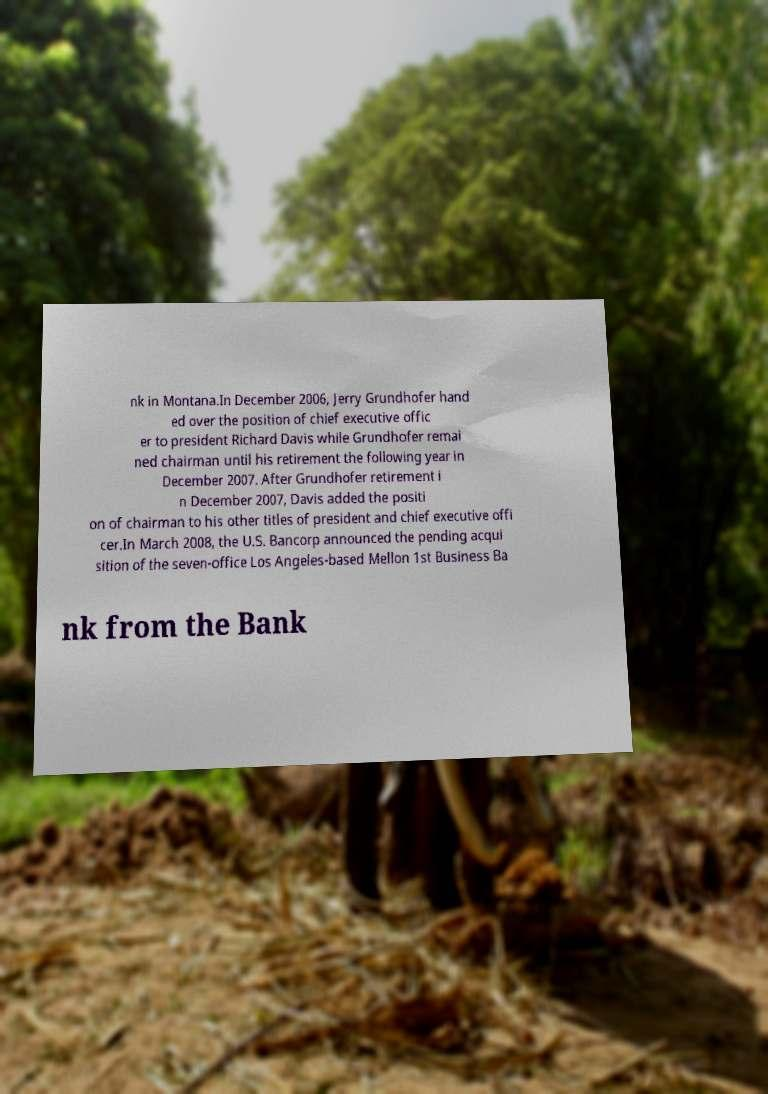What messages or text are displayed in this image? I need them in a readable, typed format. nk in Montana.In December 2006, Jerry Grundhofer hand ed over the position of chief executive offic er to president Richard Davis while Grundhofer remai ned chairman until his retirement the following year in December 2007. After Grundhofer retirement i n December 2007, Davis added the positi on of chairman to his other titles of president and chief executive offi cer.In March 2008, the U.S. Bancorp announced the pending acqui sition of the seven-office Los Angeles-based Mellon 1st Business Ba nk from the Bank 